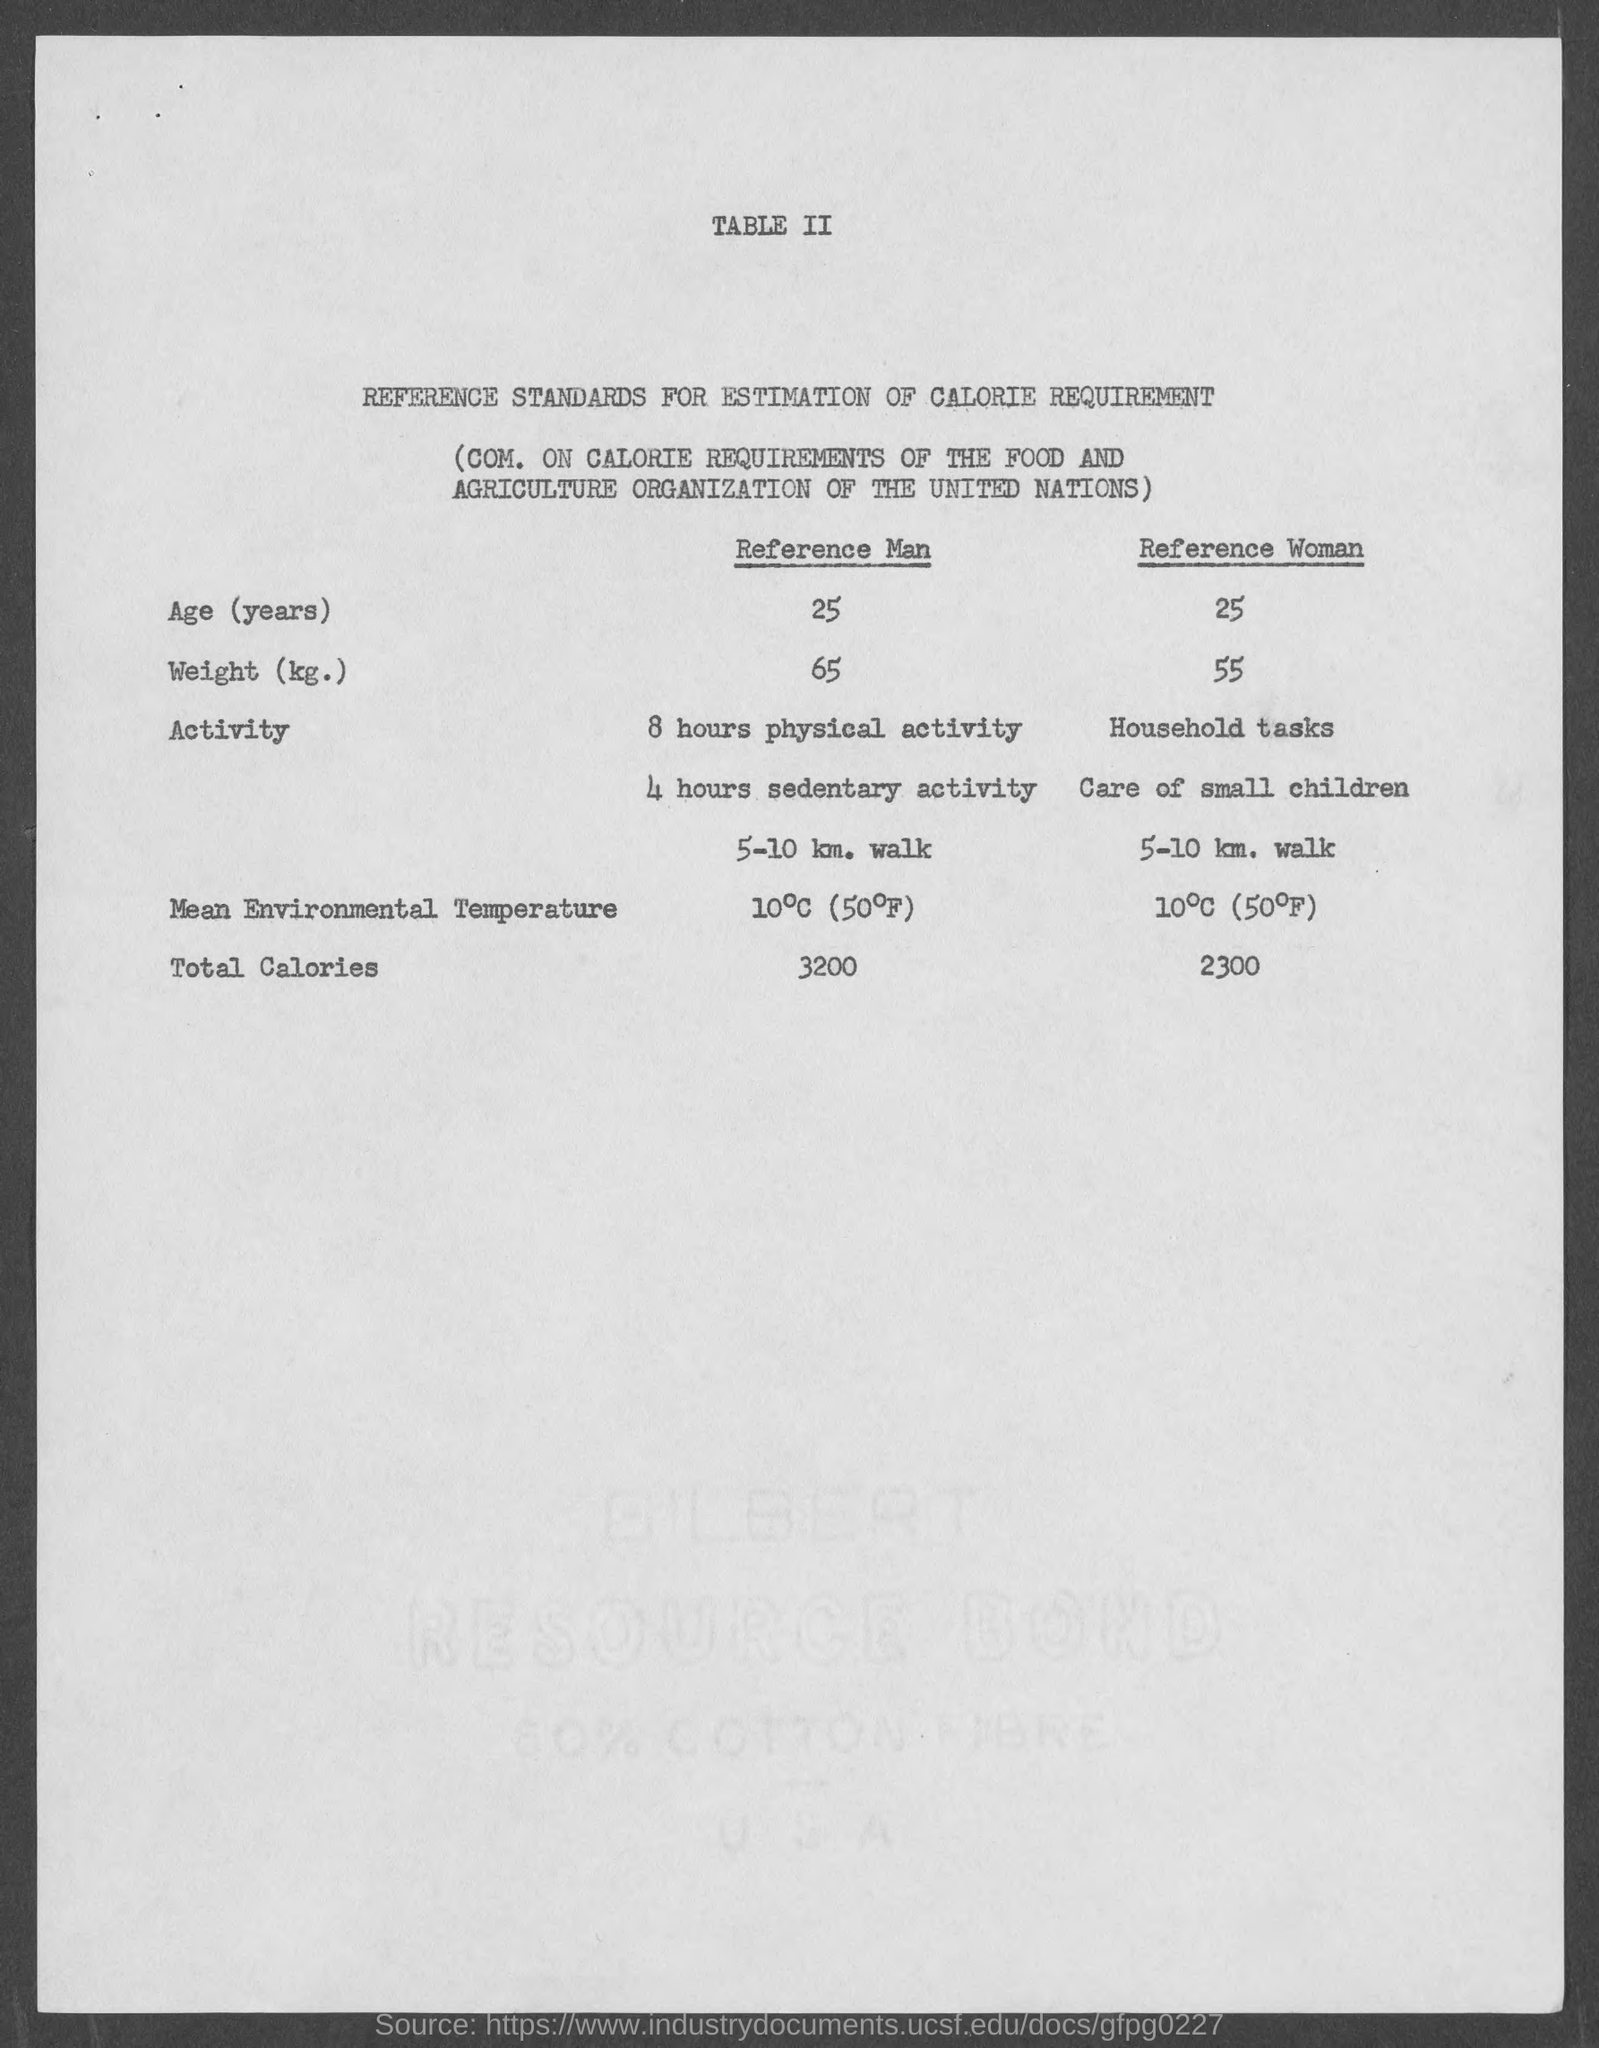Point out several critical features in this image. The total calories for a Reference Man is 3200 calories. The title of Table II is "Reference Standards for the Estimation of Calorie Requirement. The total calories for the Reference woman is 2300. 